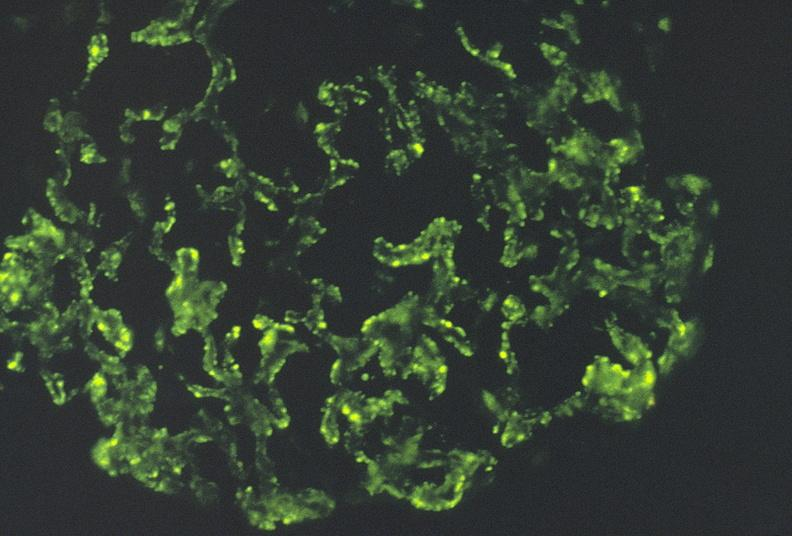what is present?
Answer the question using a single word or phrase. Urinary 